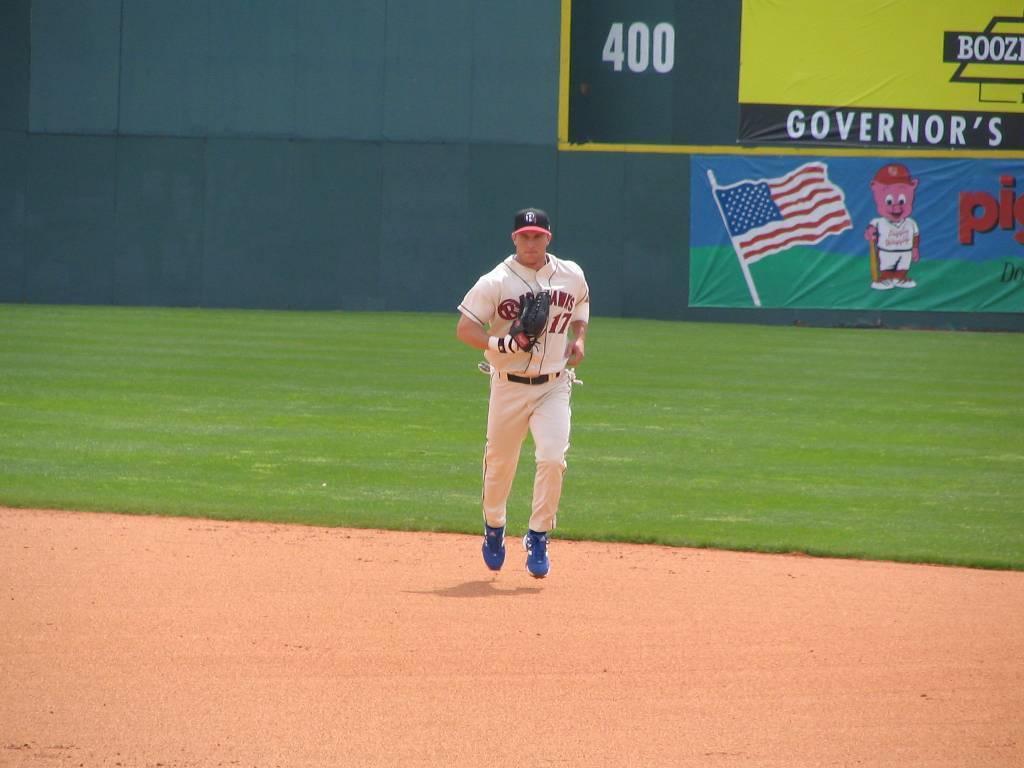What is the word found above the pig mascot in the background?
Keep it short and to the point. Governor's. What number is mentioned left of the word governor's?
Keep it short and to the point. 400. 